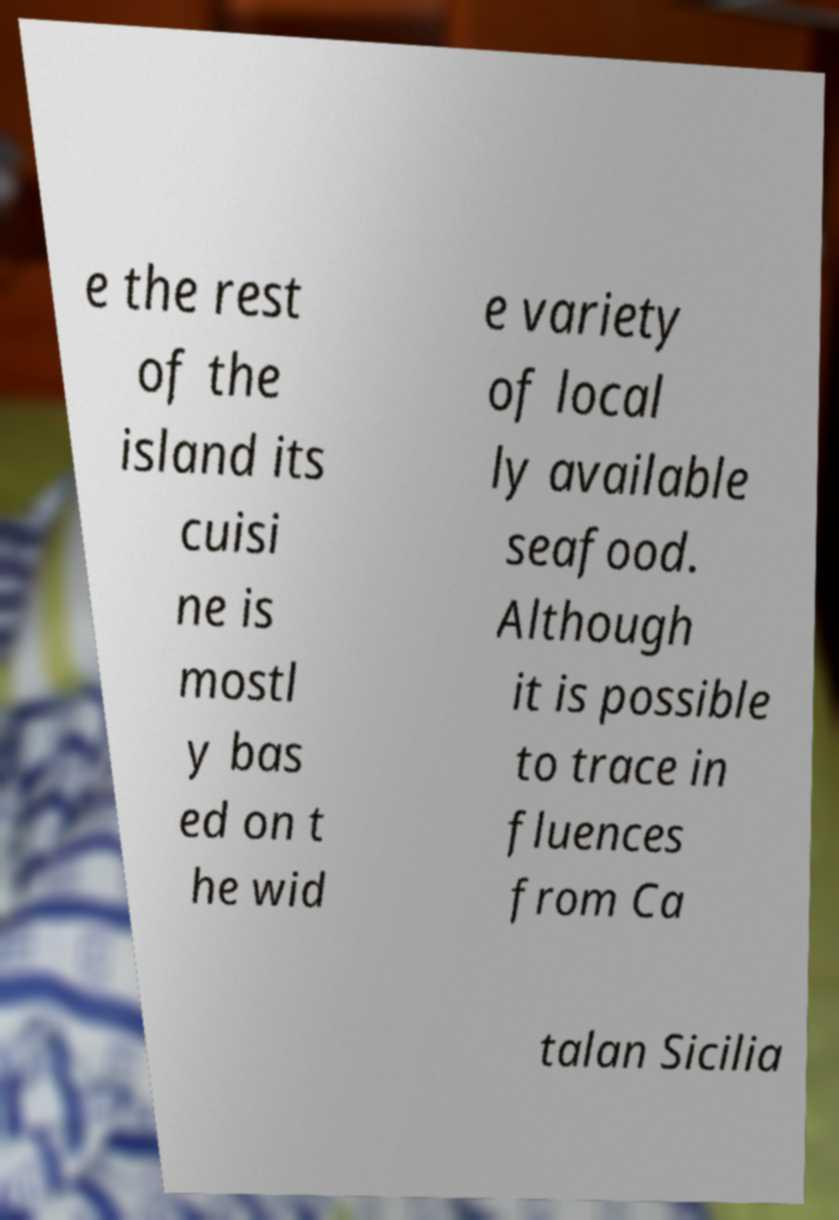I need the written content from this picture converted into text. Can you do that? e the rest of the island its cuisi ne is mostl y bas ed on t he wid e variety of local ly available seafood. Although it is possible to trace in fluences from Ca talan Sicilia 